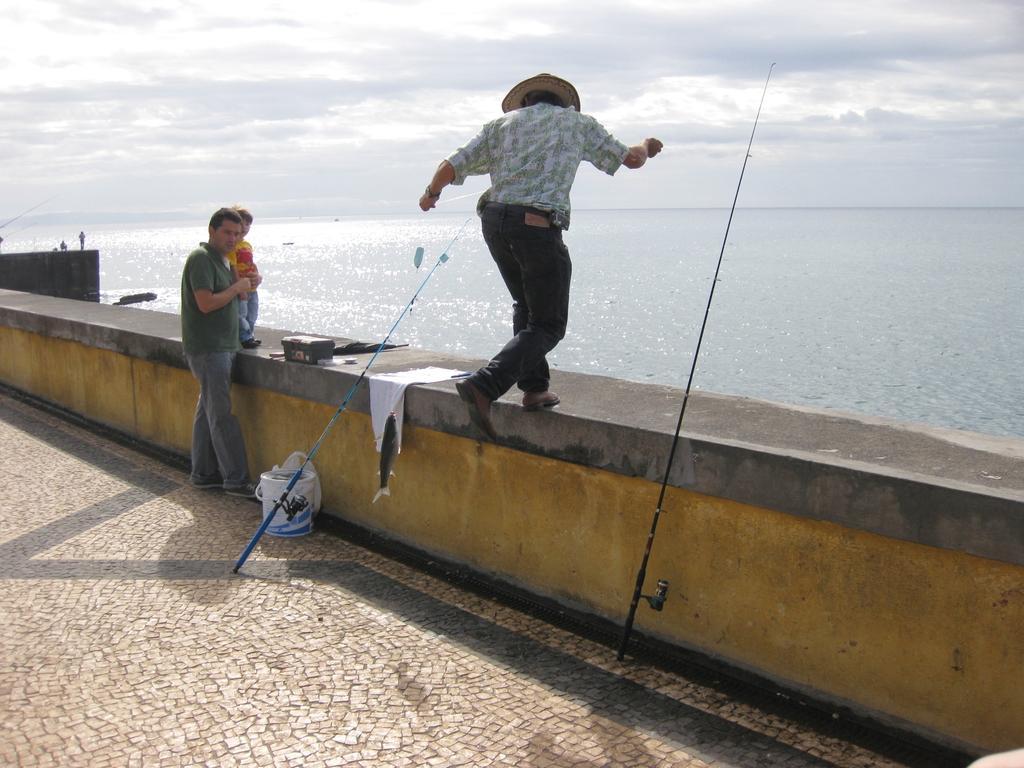In one or two sentences, can you explain what this image depicts? In this picture we can see a kid and a person wearing a hat standing on the wall. We can see a man standing. There are fishing rods, a bucket and other objects. We can see the water and the cloudy sky. 